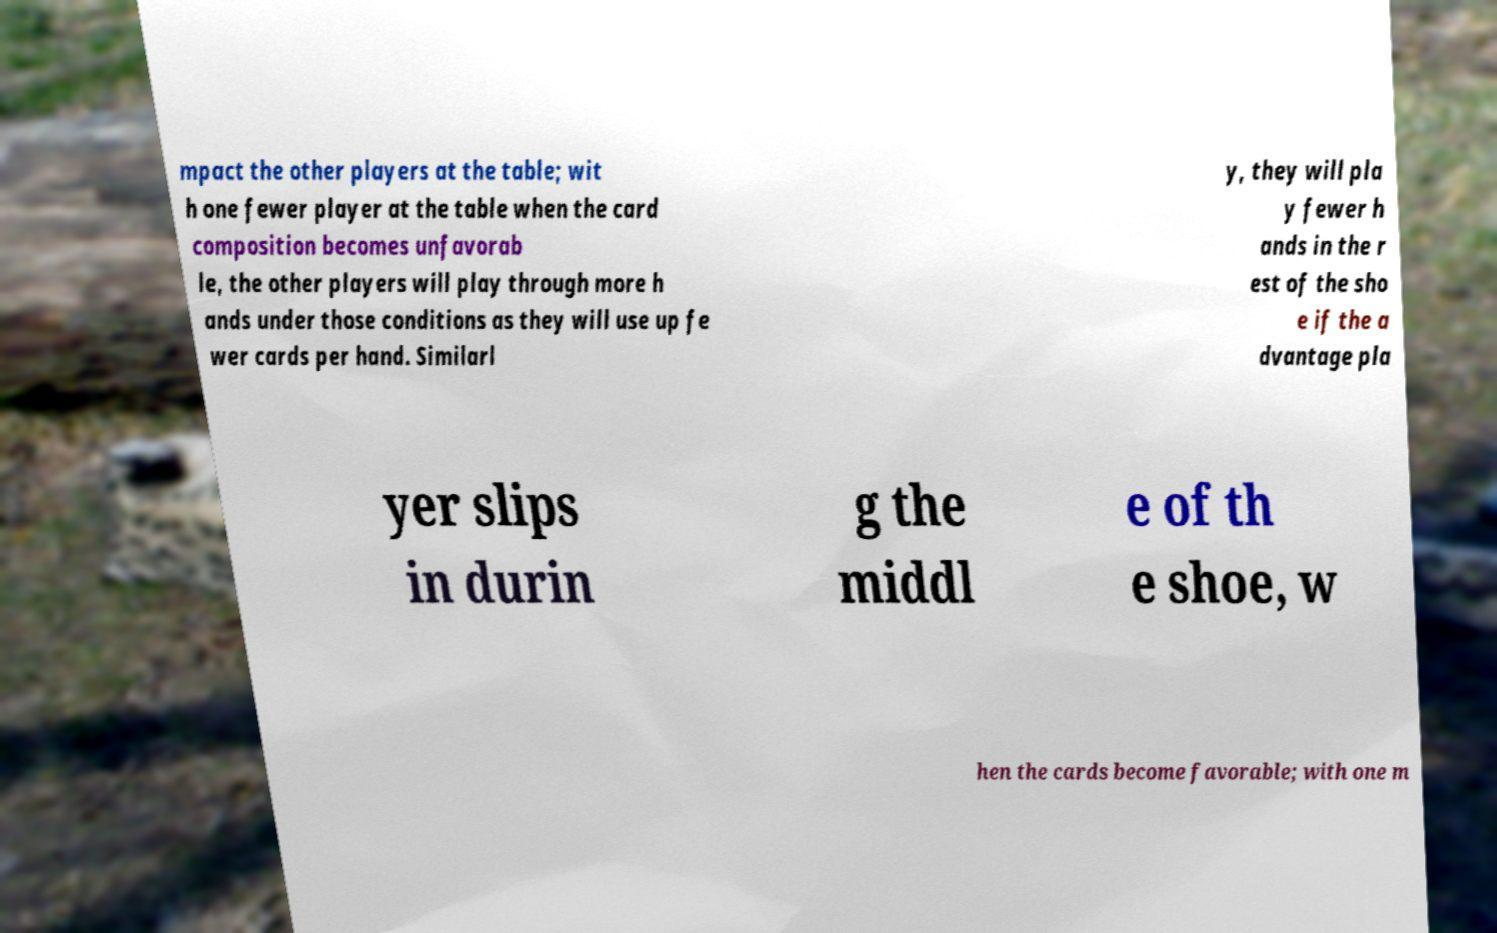For documentation purposes, I need the text within this image transcribed. Could you provide that? mpact the other players at the table; wit h one fewer player at the table when the card composition becomes unfavorab le, the other players will play through more h ands under those conditions as they will use up fe wer cards per hand. Similarl y, they will pla y fewer h ands in the r est of the sho e if the a dvantage pla yer slips in durin g the middl e of th e shoe, w hen the cards become favorable; with one m 